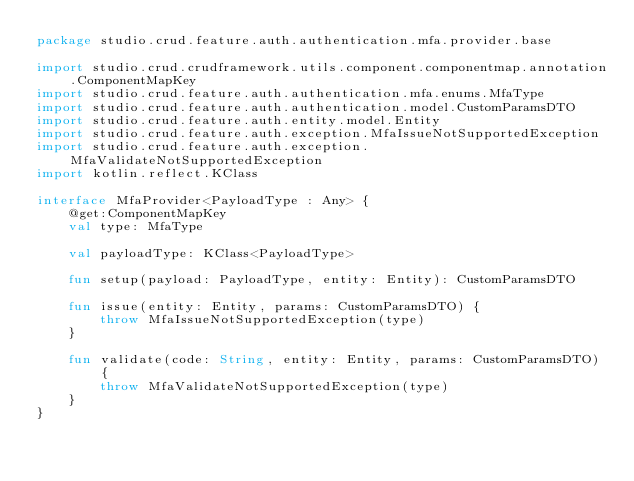<code> <loc_0><loc_0><loc_500><loc_500><_Kotlin_>package studio.crud.feature.auth.authentication.mfa.provider.base

import studio.crud.crudframework.utils.component.componentmap.annotation.ComponentMapKey
import studio.crud.feature.auth.authentication.mfa.enums.MfaType
import studio.crud.feature.auth.authentication.model.CustomParamsDTO
import studio.crud.feature.auth.entity.model.Entity
import studio.crud.feature.auth.exception.MfaIssueNotSupportedException
import studio.crud.feature.auth.exception.MfaValidateNotSupportedException
import kotlin.reflect.KClass

interface MfaProvider<PayloadType : Any> {
    @get:ComponentMapKey
    val type: MfaType

    val payloadType: KClass<PayloadType>

    fun setup(payload: PayloadType, entity: Entity): CustomParamsDTO

    fun issue(entity: Entity, params: CustomParamsDTO) {
        throw MfaIssueNotSupportedException(type)
    }

    fun validate(code: String, entity: Entity, params: CustomParamsDTO) {
        throw MfaValidateNotSupportedException(type)
    }
}</code> 